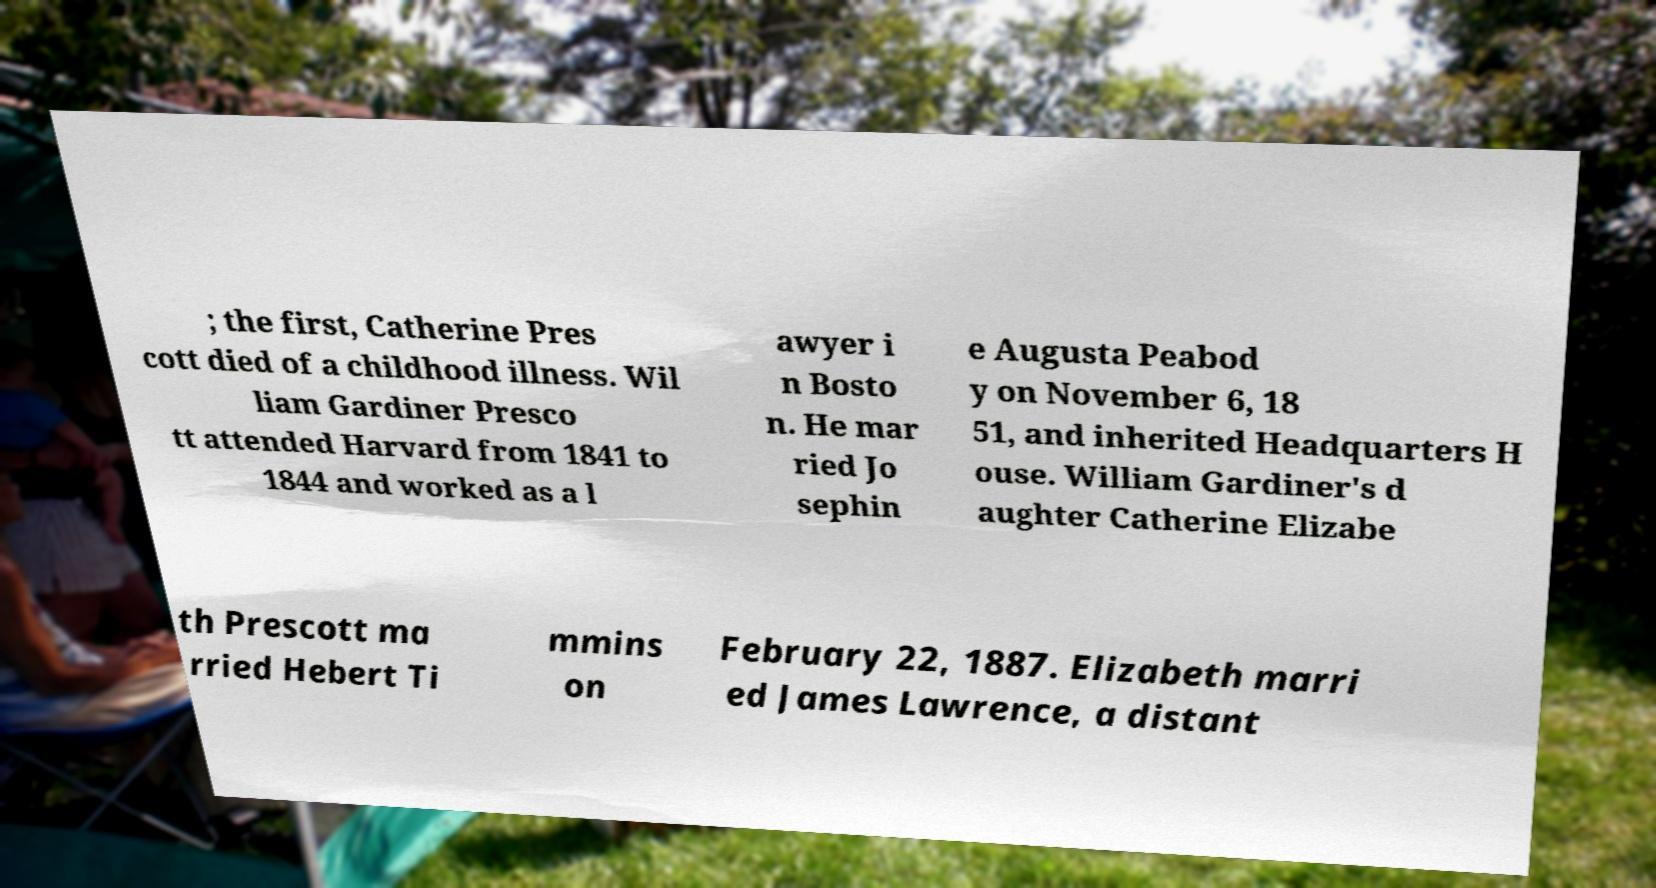I need the written content from this picture converted into text. Can you do that? ; the first, Catherine Pres cott died of a childhood illness. Wil liam Gardiner Presco tt attended Harvard from 1841 to 1844 and worked as a l awyer i n Bosto n. He mar ried Jo sephin e Augusta Peabod y on November 6, 18 51, and inherited Headquarters H ouse. William Gardiner's d aughter Catherine Elizabe th Prescott ma rried Hebert Ti mmins on February 22, 1887. Elizabeth marri ed James Lawrence, a distant 